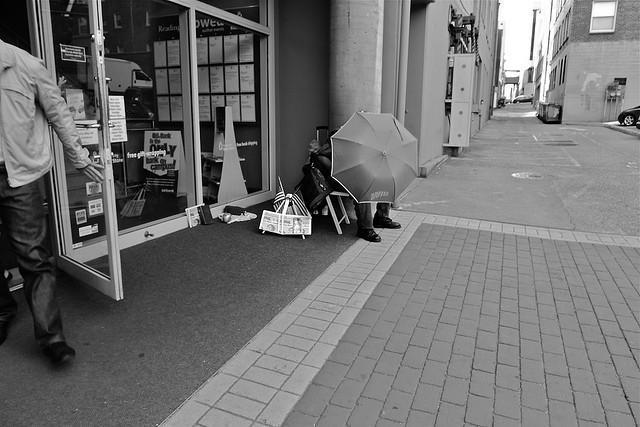How many umbrellas are pictured?
Give a very brief answer. 1. How many white cows are there?
Give a very brief answer. 0. 